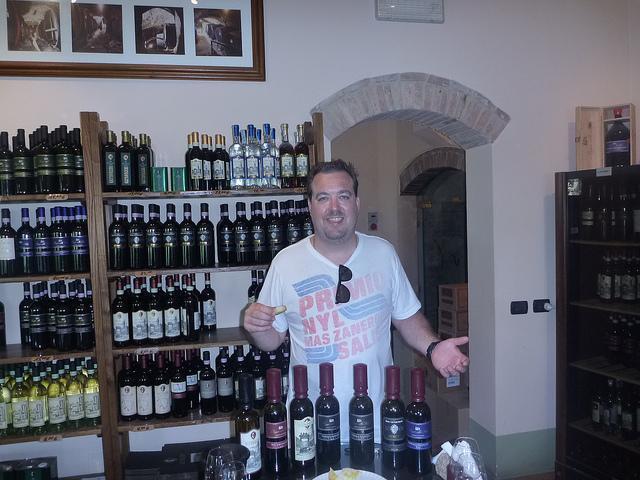How many bottles are in front of the man?
Give a very brief answer. 7. How many bottles can you see?
Give a very brief answer. 7. 